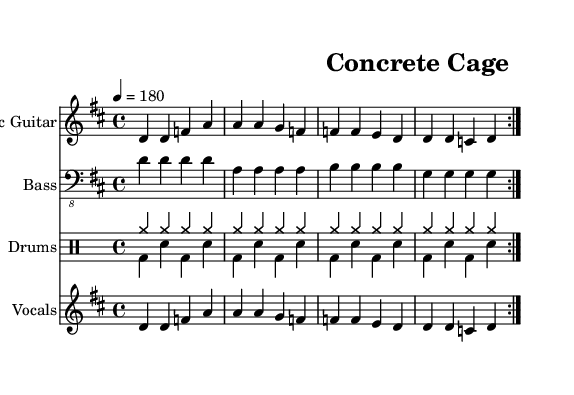What is the key signature of this music? The key signature is D major, which has two sharps (F# and C#). This can be determined by looking at the beginning of the sheet music where the key signature is indicated.
Answer: D major What is the time signature of this music? The time signature is 4/4, which means there are four beats per measure. This is indicated at the beginning of the sheet music, right after the key signature.
Answer: 4/4 What is the tempo marking in this piece? The tempo marking is 180 beats per minute, specified by the tempo indication at the start of the score. This tells us how fast the music is intended to be played.
Answer: 180 How many times is the main riff repeated? The main riff is repeated twice, as indicated by the repeat signs (volta markings) in the electric guitar and vocals parts. This shows that the specific section should be played again.
Answer: 2 What genre does this song represent? This song represents the punk genre, which is suggested by its fast tempo, straightforward lyrics, and clear structure critiquing urban life. Punk is characterized by its rebellious attitude and social commentary.
Answer: Punk What are the two primary instruments in this piece? The two primary instruments are the electric guitar and bass guitar, both of which are explicitly listed in the staff titles at the beginning of the respective staves.
Answer: Electric guitar, bass guitar What is the main theme presented in the lyrics? The main theme in the lyrics is criticising the chaotic urban lifestyle, as indicated by phrases like "Rush hour madness" and "No room to breathe." The lyrics convey a sense of frustration and critique of city living.
Answer: Urban chaos 